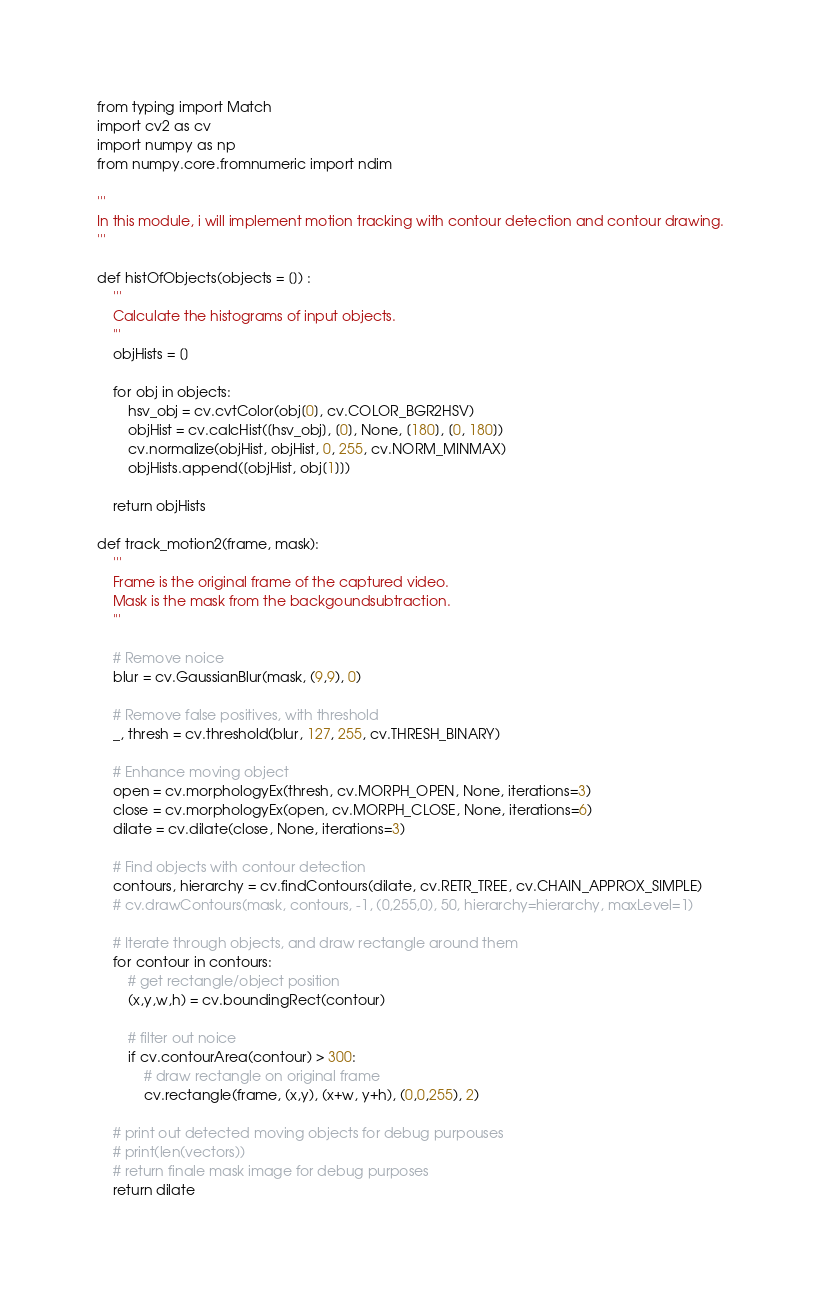Convert code to text. <code><loc_0><loc_0><loc_500><loc_500><_Python_>from typing import Match
import cv2 as cv
import numpy as np
from numpy.core.fromnumeric import ndim

'''
In this module, i will implement motion tracking with contour detection and contour drawing.
'''

def histOfObjects(objects = []) :
    '''
    Calculate the histograms of input objects. 
    '''
    objHists = []

    for obj in objects:
        hsv_obj = cv.cvtColor(obj[0], cv.COLOR_BGR2HSV)
        objHist = cv.calcHist([hsv_obj], [0], None, [180], [0, 180])
        cv.normalize(objHist, objHist, 0, 255, cv.NORM_MINMAX)
        objHists.append([objHist, obj[1]])

    return objHists

def track_motion2(frame, mask):
    '''
    Frame is the original frame of the captured video.  
    Mask is the mask from the backgoundsubtraction. 
    '''

    # Remove noice
    blur = cv.GaussianBlur(mask, (9,9), 0)

    # Remove false positives, with threshold
    _, thresh = cv.threshold(blur, 127, 255, cv.THRESH_BINARY)

    # Enhance moving object
    open = cv.morphologyEx(thresh, cv.MORPH_OPEN, None, iterations=3)
    close = cv.morphologyEx(open, cv.MORPH_CLOSE, None, iterations=6)
    dilate = cv.dilate(close, None, iterations=3)

    # Find objects with contour detection
    contours, hierarchy = cv.findContours(dilate, cv.RETR_TREE, cv.CHAIN_APPROX_SIMPLE)
    # cv.drawContours(mask, contours, -1, (0,255,0), 50, hierarchy=hierarchy, maxLevel=1)

    # Iterate through objects, and draw rectangle around them
    for contour in contours:
        # get rectangle/object position
        (x,y,w,h) = cv.boundingRect(contour)

        # filter out noice
        if cv.contourArea(contour) > 300:          
            # draw rectangle on original frame
            cv.rectangle(frame, (x,y), (x+w, y+h), (0,0,255), 2)
            
    # print out detected moving objects for debug purpouses
    # print(len(vectors))
    # return finale mask image for debug purposes
    return dilate</code> 